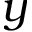<formula> <loc_0><loc_0><loc_500><loc_500>y</formula> 